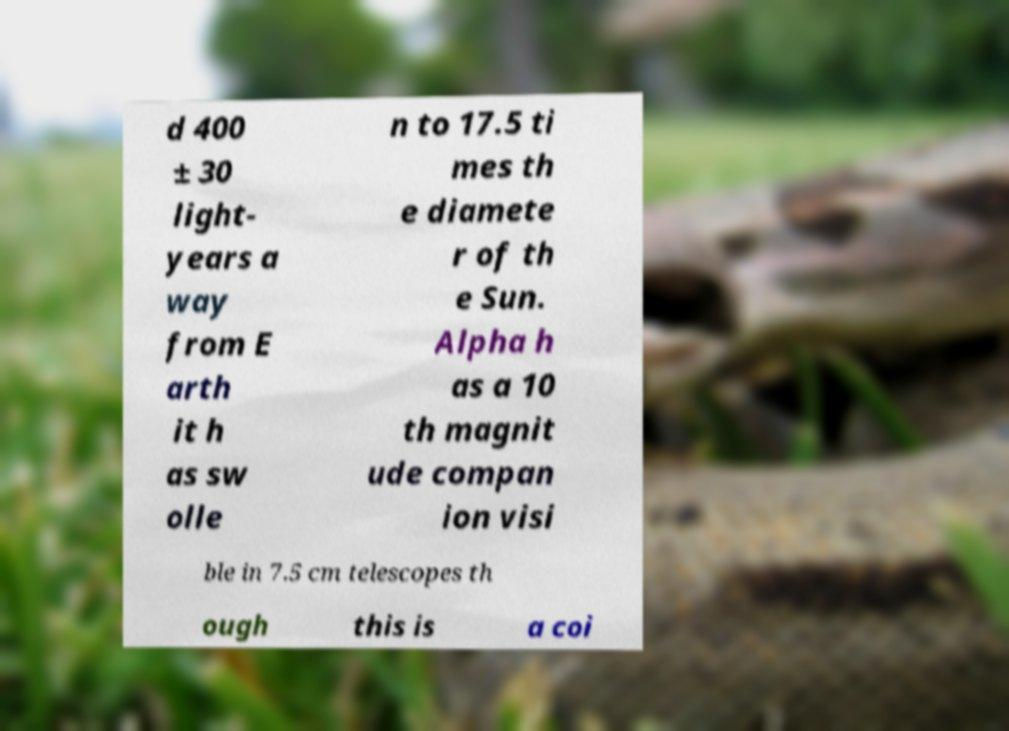There's text embedded in this image that I need extracted. Can you transcribe it verbatim? d 400 ± 30 light- years a way from E arth it h as sw olle n to 17.5 ti mes th e diamete r of th e Sun. Alpha h as a 10 th magnit ude compan ion visi ble in 7.5 cm telescopes th ough this is a coi 